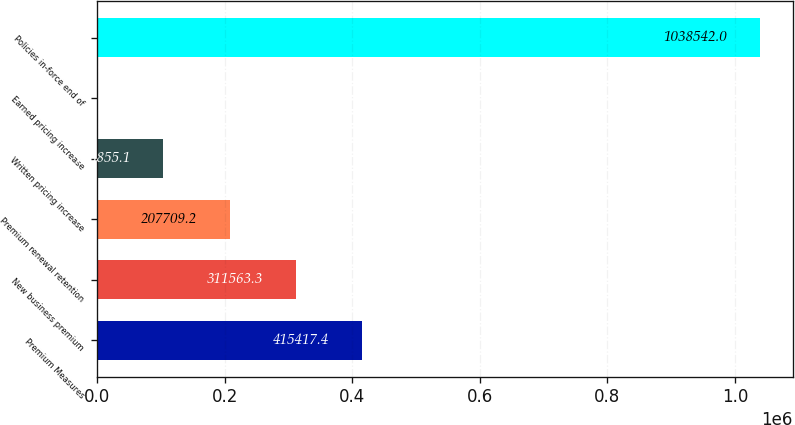Convert chart. <chart><loc_0><loc_0><loc_500><loc_500><bar_chart><fcel>Premium Measures<fcel>New business premium<fcel>Premium renewal retention<fcel>Written pricing increase<fcel>Earned pricing increase<fcel>Policies in-force end of<nl><fcel>415417<fcel>311563<fcel>207709<fcel>103855<fcel>1<fcel>1.03854e+06<nl></chart> 